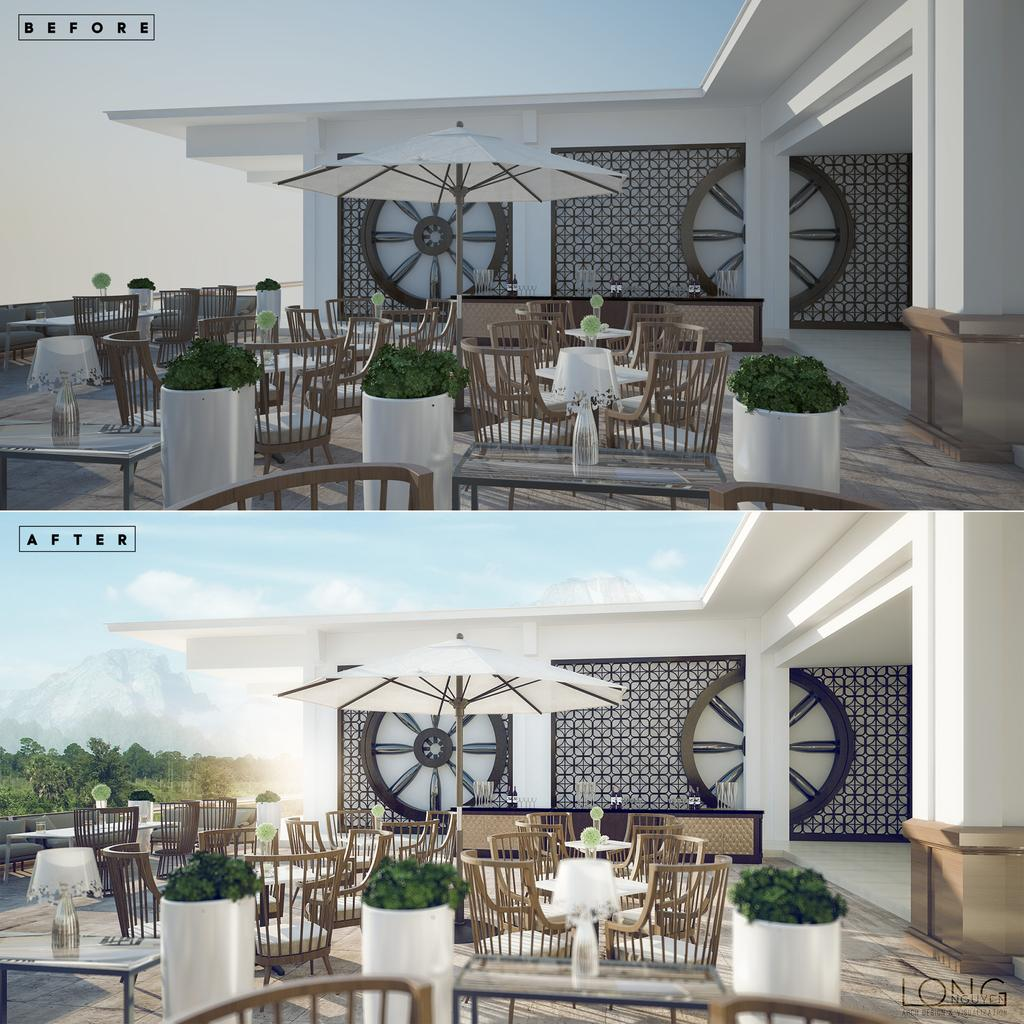What type of artwork is the image? The image is a collage of two images. What structures can be seen in the image? There are buildings in the image. What type of vegetation is present in the image? There are plants and trees in the image. What type of furniture is visible in the image? There are chairs in the image. What type of lighting is present in the image? There are lights in the image. What natural elements can be seen in the image? There are trees and clouds in the image. Is there any text present in the image? Yes, there is some text in the image. What direction is the snake moving in the image? There is no snake present in the image. 